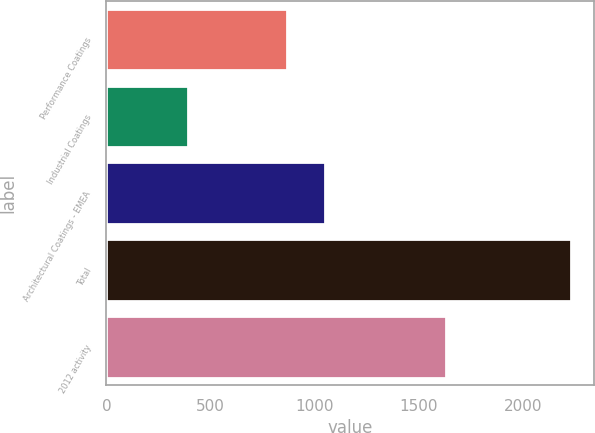Convert chart to OTSL. <chart><loc_0><loc_0><loc_500><loc_500><bar_chart><fcel>Performance Coatings<fcel>Industrial Coatings<fcel>Architectural Coatings - EMEA<fcel>Total<fcel>2012 activity<nl><fcel>867<fcel>394<fcel>1050.8<fcel>2232<fcel>1631<nl></chart> 